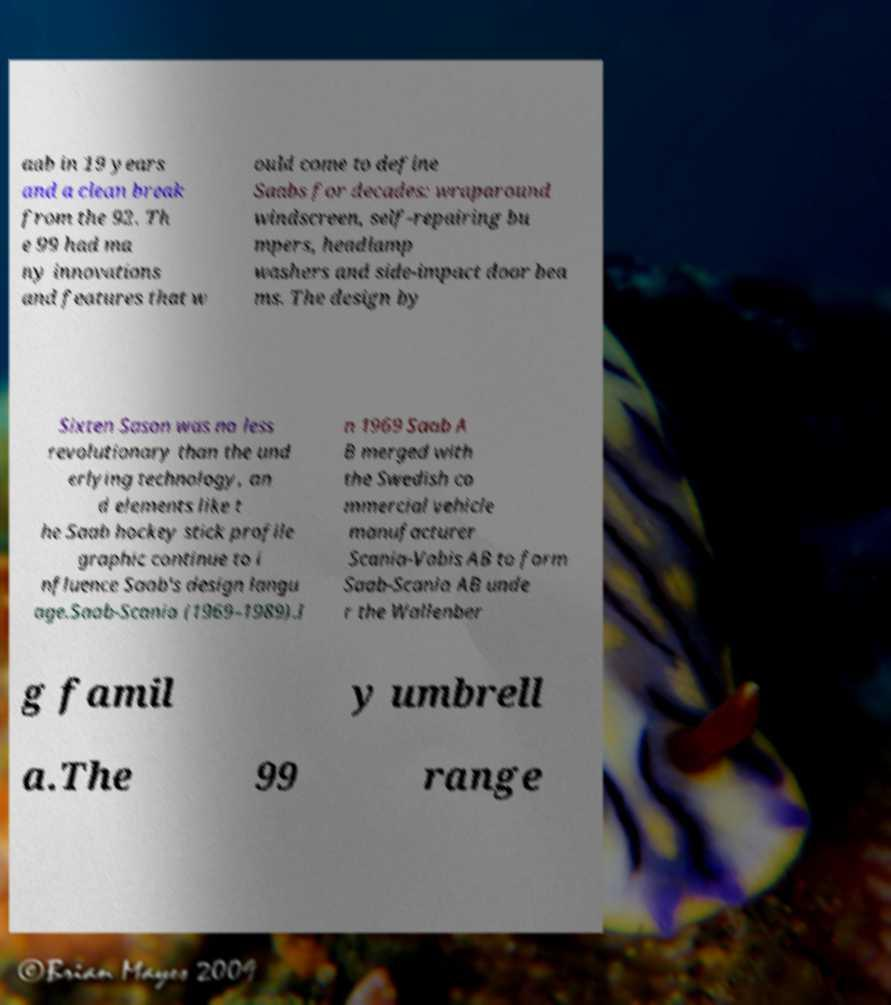Please read and relay the text visible in this image. What does it say? aab in 19 years and a clean break from the 92. Th e 99 had ma ny innovations and features that w ould come to define Saabs for decades: wraparound windscreen, self-repairing bu mpers, headlamp washers and side-impact door bea ms. The design by Sixten Sason was no less revolutionary than the und erlying technology, an d elements like t he Saab hockey stick profile graphic continue to i nfluence Saab's design langu age.Saab-Scania (1969–1989).I n 1969 Saab A B merged with the Swedish co mmercial vehicle manufacturer Scania-Vabis AB to form Saab-Scania AB unde r the Wallenber g famil y umbrell a.The 99 range 